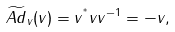Convert formula to latex. <formula><loc_0><loc_0><loc_500><loc_500>\widetilde { A d } _ { v } ( v ) = v ^ { ^ { * } } v v ^ { - 1 } = - v ,</formula> 